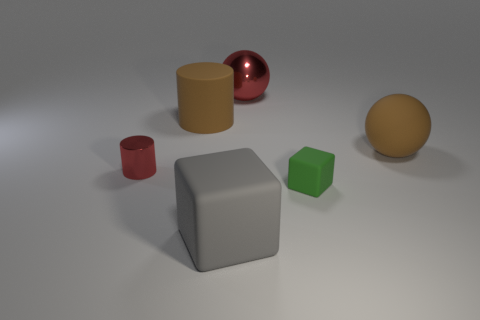Add 1 tiny matte cubes. How many objects exist? 7 Subtract all cubes. How many objects are left? 4 Subtract all small objects. Subtract all brown rubber blocks. How many objects are left? 4 Add 6 gray rubber blocks. How many gray rubber blocks are left? 7 Add 3 big blue balls. How many big blue balls exist? 3 Subtract 0 cyan balls. How many objects are left? 6 